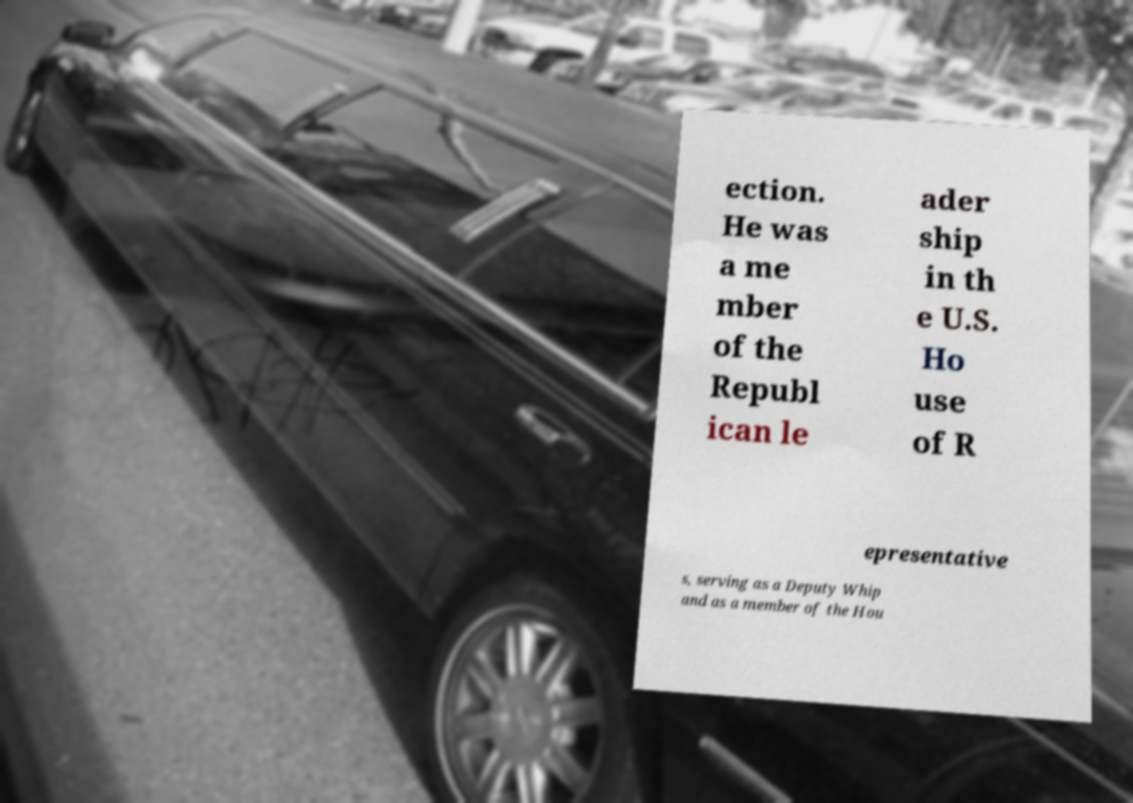I need the written content from this picture converted into text. Can you do that? ection. He was a me mber of the Republ ican le ader ship in th e U.S. Ho use of R epresentative s, serving as a Deputy Whip and as a member of the Hou 